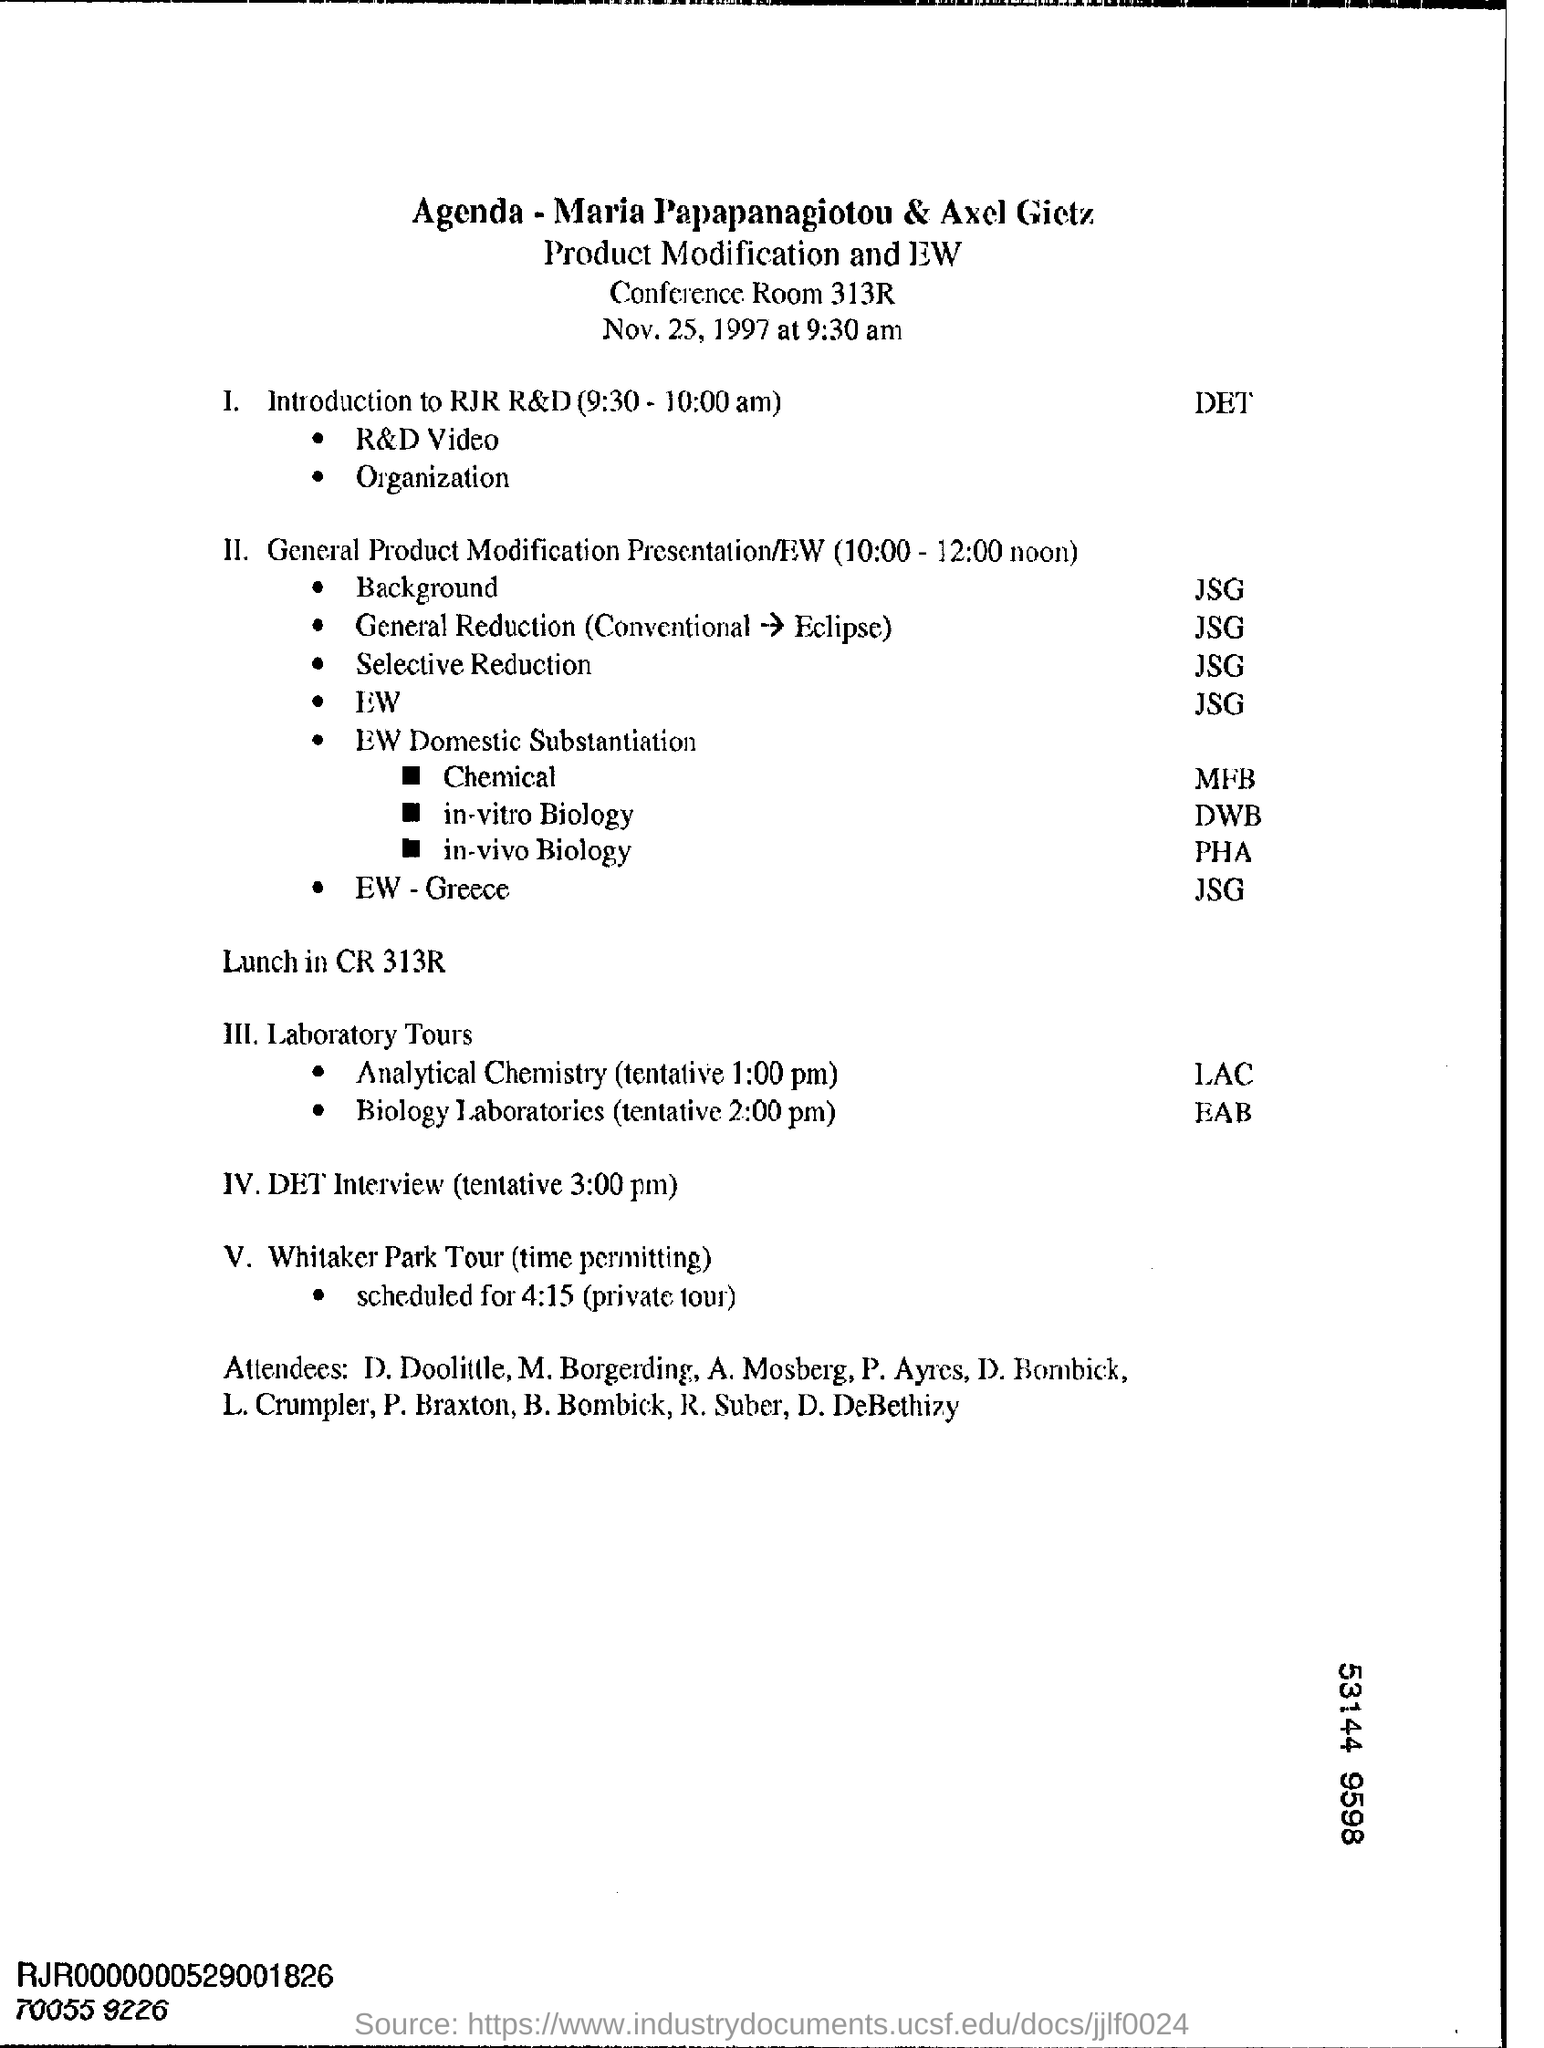What is the venue for lunch ?
Your answer should be very brief. Cr 313r. What is tentative time for det interview ?
Offer a terse response. 3:00 pm. 